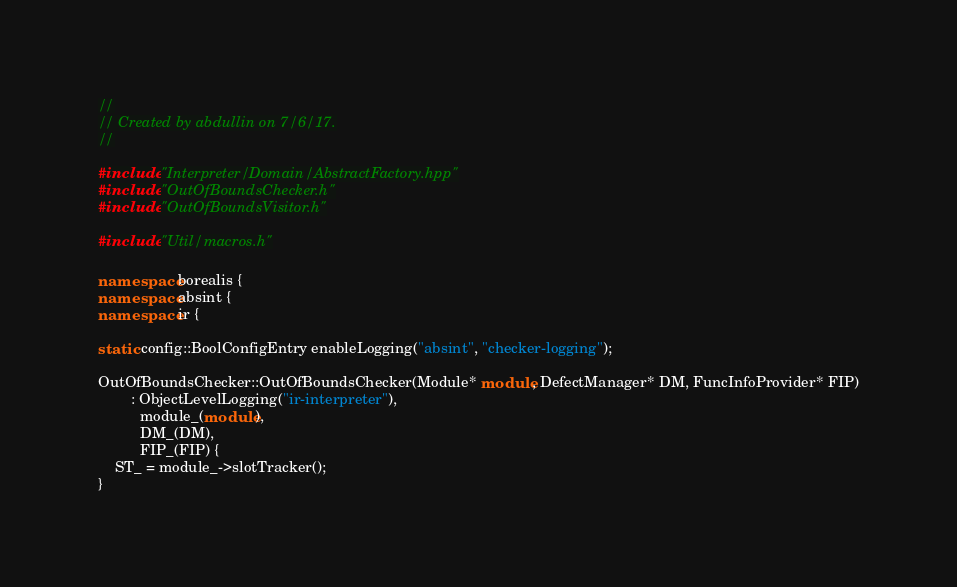<code> <loc_0><loc_0><loc_500><loc_500><_C++_>//
// Created by abdullin on 7/6/17.
//

#include "Interpreter/Domain/AbstractFactory.hpp"
#include "OutOfBoundsChecker.h"
#include "OutOfBoundsVisitor.h"

#include "Util/macros.h"

namespace borealis {
namespace absint {
namespace ir {

static config::BoolConfigEntry enableLogging("absint", "checker-logging");

OutOfBoundsChecker::OutOfBoundsChecker(Module* module, DefectManager* DM, FuncInfoProvider* FIP)
        : ObjectLevelLogging("ir-interpreter"),
          module_(module),
          DM_(DM),
          FIP_(FIP) {
    ST_ = module_->slotTracker();
}
</code> 